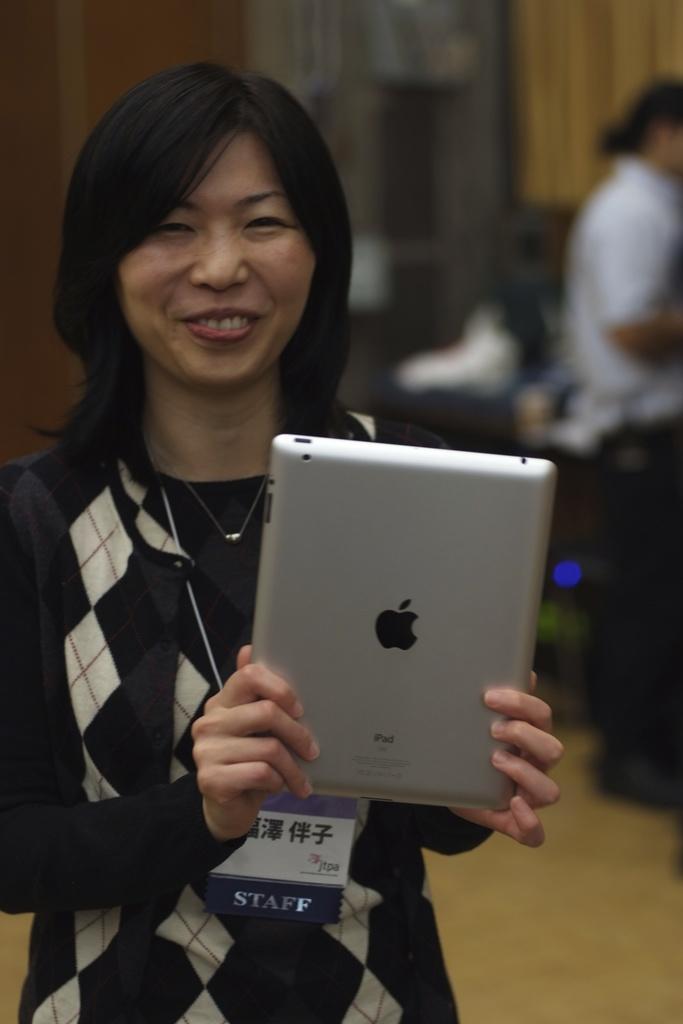Could you give a brief overview of what you see in this image? There is one woman standing and holding an electronic device as we can see on the left side of this image. There is one other person standing on the right side of this image and we can see a wall in the background. 